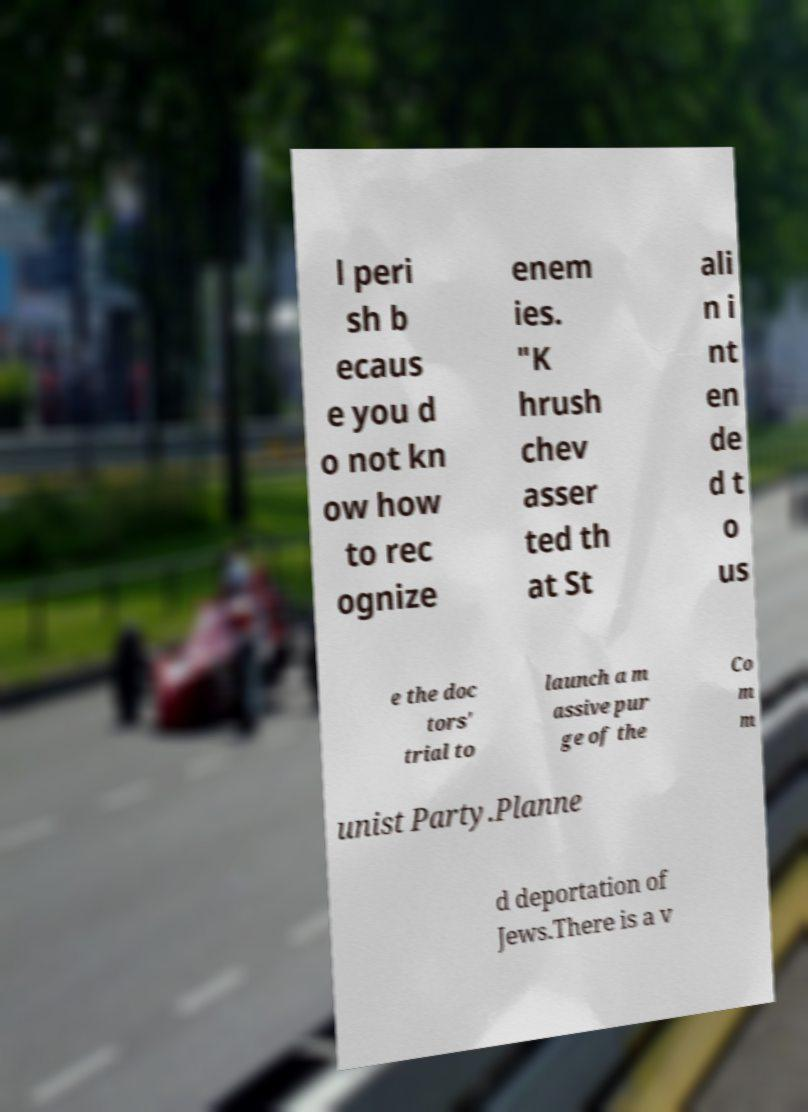There's text embedded in this image that I need extracted. Can you transcribe it verbatim? l peri sh b ecaus e you d o not kn ow how to rec ognize enem ies. "K hrush chev asser ted th at St ali n i nt en de d t o us e the doc tors' trial to launch a m assive pur ge of the Co m m unist Party.Planne d deportation of Jews.There is a v 